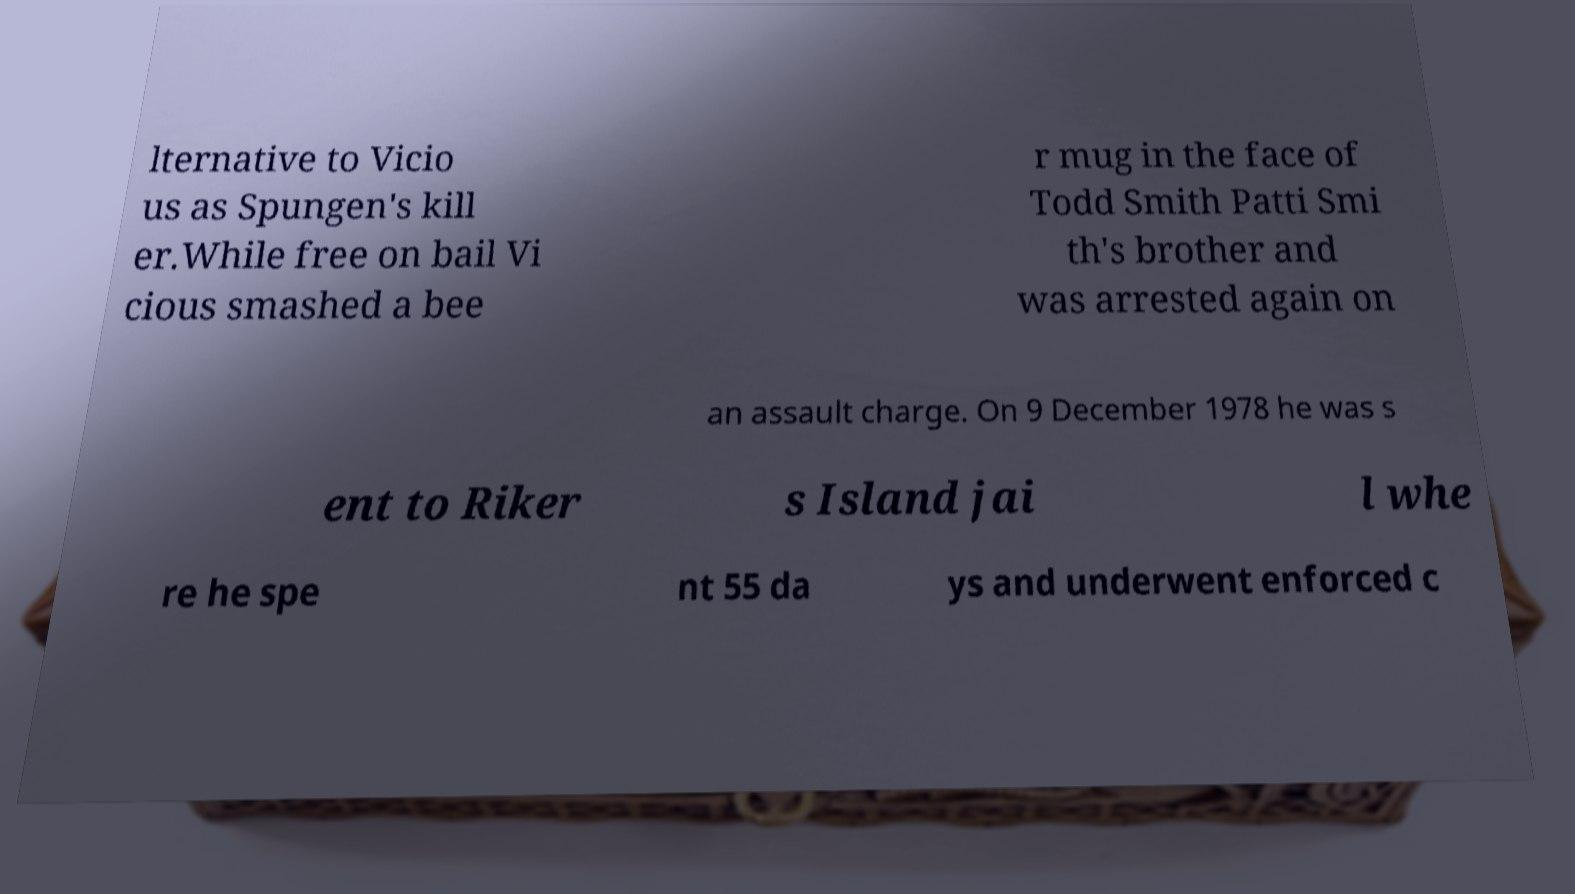There's text embedded in this image that I need extracted. Can you transcribe it verbatim? lternative to Vicio us as Spungen's kill er.While free on bail Vi cious smashed a bee r mug in the face of Todd Smith Patti Smi th's brother and was arrested again on an assault charge. On 9 December 1978 he was s ent to Riker s Island jai l whe re he spe nt 55 da ys and underwent enforced c 